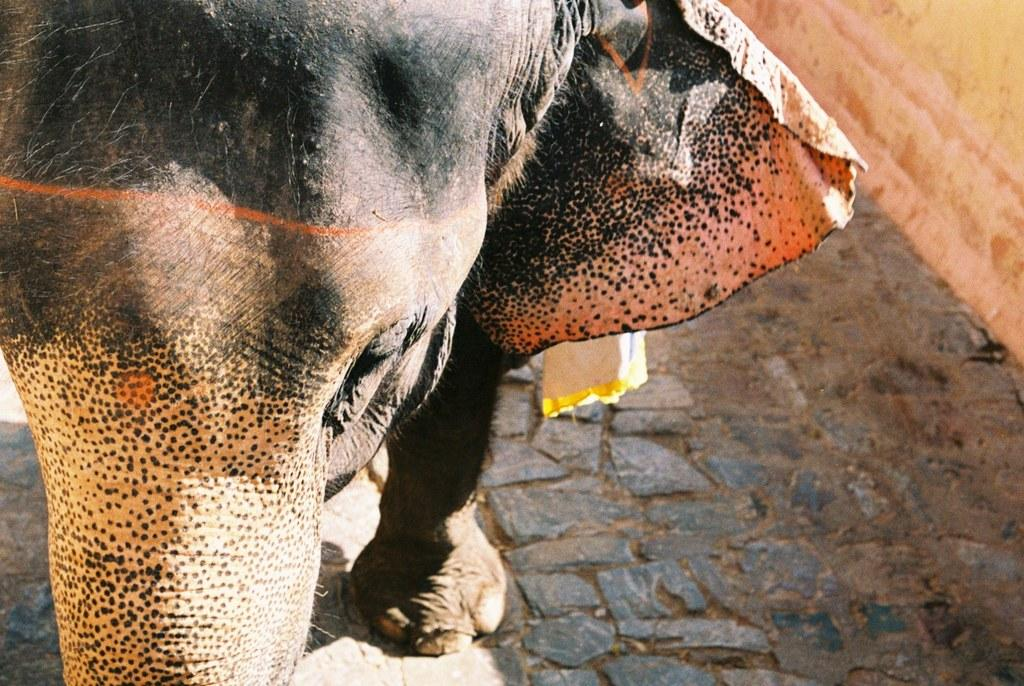What animal is the main subject of the image? There is an elephant in the image. What type of surface is the elephant standing on? The elephant is on a stone surface. What can be seen in the top right corner of the image? There is a wall on the right side top corner of the image. What type of material is visible in the image? There is cloth visible in the image. What type of teeth can be seen in the image? There are no teeth visible in the image, as it features an elephant on a stone surface with a wall and cloth in the background. 